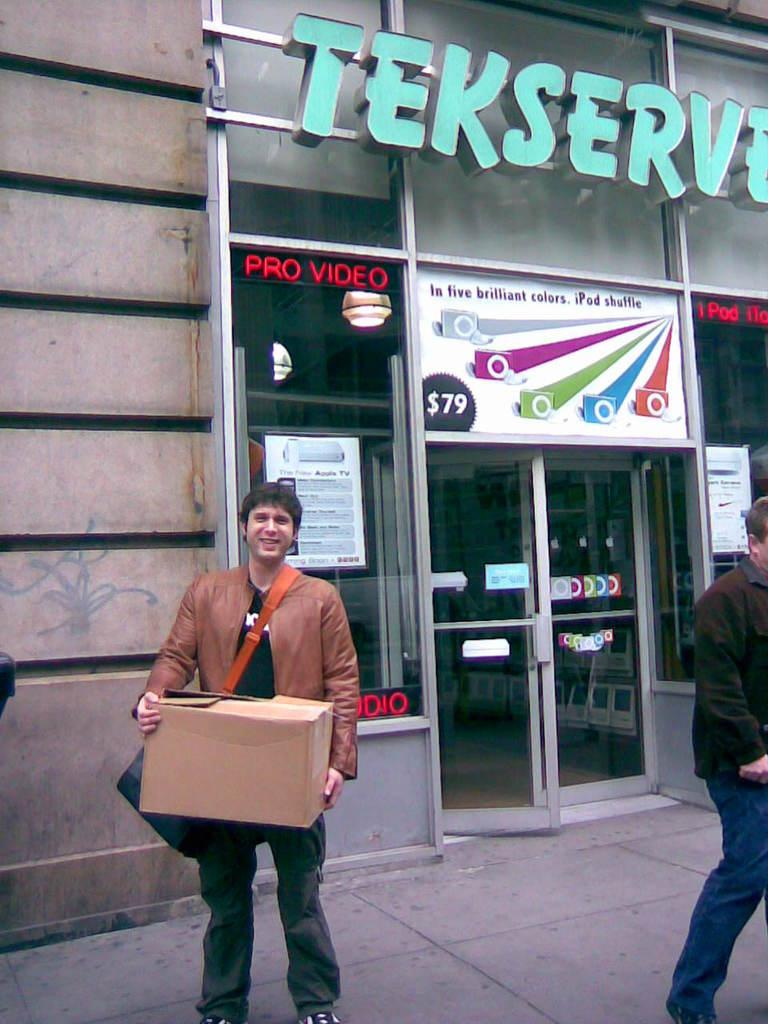Who is the main subject in the image? There is a man in the image. Can you describe the man's position in the image? The man is standing in the front. What is the man holding in his hand? The man is holding a brown cardboard box in his hand. What can be seen in the background of the image? There is a shop glass door and a brown wall in the background. What type of oil can be seen dripping from the man's hand in the image? There is no oil present in the image, and the man's hand is not shown to be dripping anything. 